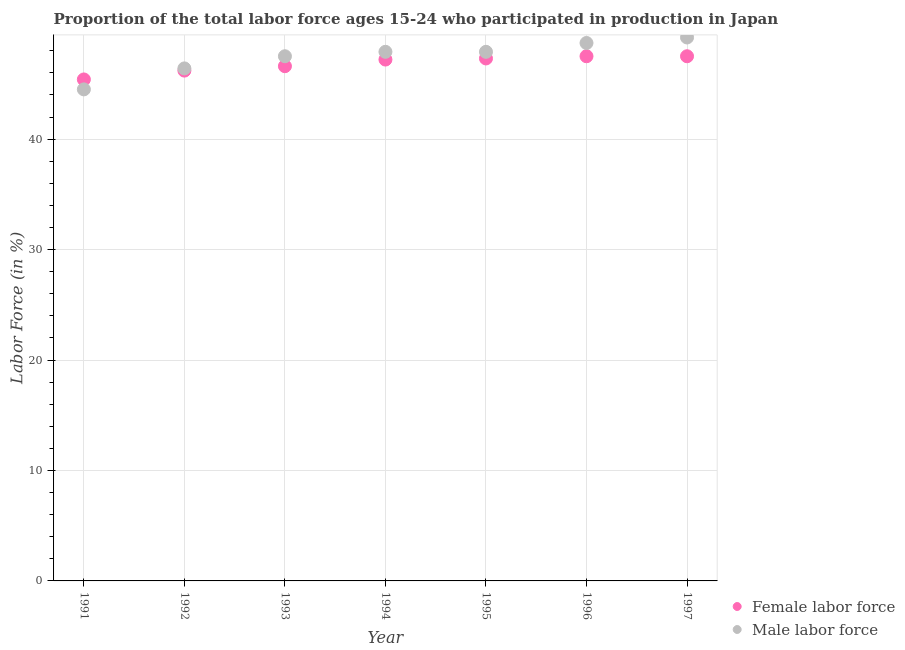What is the percentage of female labor force in 1992?
Make the answer very short. 46.2. Across all years, what is the maximum percentage of male labour force?
Offer a very short reply. 49.2. Across all years, what is the minimum percentage of male labour force?
Offer a terse response. 44.5. In which year was the percentage of male labour force maximum?
Provide a succinct answer. 1997. In which year was the percentage of male labour force minimum?
Your answer should be very brief. 1991. What is the total percentage of female labor force in the graph?
Make the answer very short. 327.7. What is the difference between the percentage of male labour force in 1994 and that in 1996?
Ensure brevity in your answer.  -0.8. What is the difference between the percentage of female labor force in 1995 and the percentage of male labour force in 1992?
Offer a very short reply. 0.9. What is the average percentage of female labor force per year?
Give a very brief answer. 46.81. In the year 1991, what is the difference between the percentage of female labor force and percentage of male labour force?
Offer a terse response. 0.9. What is the ratio of the percentage of male labour force in 1991 to that in 1997?
Offer a terse response. 0.9. Is the percentage of female labor force in 1994 less than that in 1997?
Ensure brevity in your answer.  Yes. Is the difference between the percentage of female labor force in 1995 and 1996 greater than the difference between the percentage of male labour force in 1995 and 1996?
Provide a succinct answer. Yes. What is the difference between the highest and the lowest percentage of female labor force?
Your answer should be compact. 2.1. In how many years, is the percentage of male labour force greater than the average percentage of male labour force taken over all years?
Give a very brief answer. 5. Does the percentage of female labor force monotonically increase over the years?
Offer a very short reply. No. How many dotlines are there?
Offer a very short reply. 2. Does the graph contain any zero values?
Give a very brief answer. No. Does the graph contain grids?
Make the answer very short. Yes. Where does the legend appear in the graph?
Ensure brevity in your answer.  Bottom right. How many legend labels are there?
Offer a terse response. 2. How are the legend labels stacked?
Offer a terse response. Vertical. What is the title of the graph?
Offer a terse response. Proportion of the total labor force ages 15-24 who participated in production in Japan. What is the label or title of the X-axis?
Provide a succinct answer. Year. What is the Labor Force (in %) in Female labor force in 1991?
Ensure brevity in your answer.  45.4. What is the Labor Force (in %) of Male labor force in 1991?
Provide a succinct answer. 44.5. What is the Labor Force (in %) of Female labor force in 1992?
Give a very brief answer. 46.2. What is the Labor Force (in %) of Male labor force in 1992?
Your response must be concise. 46.4. What is the Labor Force (in %) in Female labor force in 1993?
Keep it short and to the point. 46.6. What is the Labor Force (in %) of Male labor force in 1993?
Offer a very short reply. 47.5. What is the Labor Force (in %) in Female labor force in 1994?
Keep it short and to the point. 47.2. What is the Labor Force (in %) in Male labor force in 1994?
Ensure brevity in your answer.  47.9. What is the Labor Force (in %) in Female labor force in 1995?
Offer a very short reply. 47.3. What is the Labor Force (in %) of Male labor force in 1995?
Your answer should be very brief. 47.9. What is the Labor Force (in %) in Female labor force in 1996?
Ensure brevity in your answer.  47.5. What is the Labor Force (in %) of Male labor force in 1996?
Keep it short and to the point. 48.7. What is the Labor Force (in %) of Female labor force in 1997?
Offer a terse response. 47.5. What is the Labor Force (in %) of Male labor force in 1997?
Provide a short and direct response. 49.2. Across all years, what is the maximum Labor Force (in %) of Female labor force?
Keep it short and to the point. 47.5. Across all years, what is the maximum Labor Force (in %) of Male labor force?
Make the answer very short. 49.2. Across all years, what is the minimum Labor Force (in %) of Female labor force?
Provide a short and direct response. 45.4. Across all years, what is the minimum Labor Force (in %) of Male labor force?
Your answer should be compact. 44.5. What is the total Labor Force (in %) in Female labor force in the graph?
Offer a very short reply. 327.7. What is the total Labor Force (in %) in Male labor force in the graph?
Your answer should be very brief. 332.1. What is the difference between the Labor Force (in %) of Female labor force in 1991 and that in 1995?
Ensure brevity in your answer.  -1.9. What is the difference between the Labor Force (in %) of Female labor force in 1992 and that in 1993?
Your answer should be very brief. -0.4. What is the difference between the Labor Force (in %) of Male labor force in 1992 and that in 1993?
Offer a terse response. -1.1. What is the difference between the Labor Force (in %) of Female labor force in 1992 and that in 1994?
Ensure brevity in your answer.  -1. What is the difference between the Labor Force (in %) of Male labor force in 1992 and that in 1994?
Provide a short and direct response. -1.5. What is the difference between the Labor Force (in %) of Female labor force in 1992 and that in 1995?
Ensure brevity in your answer.  -1.1. What is the difference between the Labor Force (in %) of Male labor force in 1992 and that in 1995?
Offer a terse response. -1.5. What is the difference between the Labor Force (in %) of Male labor force in 1992 and that in 1996?
Your answer should be compact. -2.3. What is the difference between the Labor Force (in %) of Female labor force in 1992 and that in 1997?
Ensure brevity in your answer.  -1.3. What is the difference between the Labor Force (in %) in Male labor force in 1992 and that in 1997?
Offer a terse response. -2.8. What is the difference between the Labor Force (in %) of Female labor force in 1993 and that in 1994?
Keep it short and to the point. -0.6. What is the difference between the Labor Force (in %) in Male labor force in 1993 and that in 1994?
Provide a short and direct response. -0.4. What is the difference between the Labor Force (in %) in Male labor force in 1993 and that in 1995?
Give a very brief answer. -0.4. What is the difference between the Labor Force (in %) in Female labor force in 1993 and that in 1997?
Your answer should be very brief. -0.9. What is the difference between the Labor Force (in %) in Male labor force in 1993 and that in 1997?
Your answer should be compact. -1.7. What is the difference between the Labor Force (in %) of Male labor force in 1994 and that in 1995?
Ensure brevity in your answer.  0. What is the difference between the Labor Force (in %) of Female labor force in 1994 and that in 1996?
Offer a very short reply. -0.3. What is the difference between the Labor Force (in %) of Male labor force in 1994 and that in 1996?
Ensure brevity in your answer.  -0.8. What is the difference between the Labor Force (in %) in Female labor force in 1995 and that in 1996?
Your response must be concise. -0.2. What is the difference between the Labor Force (in %) in Male labor force in 1995 and that in 1996?
Offer a terse response. -0.8. What is the difference between the Labor Force (in %) of Female labor force in 1995 and that in 1997?
Keep it short and to the point. -0.2. What is the difference between the Labor Force (in %) of Male labor force in 1995 and that in 1997?
Provide a short and direct response. -1.3. What is the difference between the Labor Force (in %) in Male labor force in 1996 and that in 1997?
Ensure brevity in your answer.  -0.5. What is the difference between the Labor Force (in %) in Female labor force in 1991 and the Labor Force (in %) in Male labor force in 1992?
Make the answer very short. -1. What is the difference between the Labor Force (in %) of Female labor force in 1991 and the Labor Force (in %) of Male labor force in 1995?
Give a very brief answer. -2.5. What is the difference between the Labor Force (in %) in Female labor force in 1991 and the Labor Force (in %) in Male labor force in 1997?
Keep it short and to the point. -3.8. What is the difference between the Labor Force (in %) in Female labor force in 1992 and the Labor Force (in %) in Male labor force in 1993?
Keep it short and to the point. -1.3. What is the difference between the Labor Force (in %) in Female labor force in 1992 and the Labor Force (in %) in Male labor force in 1997?
Offer a very short reply. -3. What is the difference between the Labor Force (in %) in Female labor force in 1993 and the Labor Force (in %) in Male labor force in 1994?
Your response must be concise. -1.3. What is the difference between the Labor Force (in %) of Female labor force in 1995 and the Labor Force (in %) of Male labor force in 1996?
Offer a terse response. -1.4. What is the difference between the Labor Force (in %) of Female labor force in 1995 and the Labor Force (in %) of Male labor force in 1997?
Your answer should be very brief. -1.9. What is the average Labor Force (in %) of Female labor force per year?
Your answer should be compact. 46.81. What is the average Labor Force (in %) of Male labor force per year?
Offer a very short reply. 47.44. In the year 1991, what is the difference between the Labor Force (in %) in Female labor force and Labor Force (in %) in Male labor force?
Ensure brevity in your answer.  0.9. In the year 1993, what is the difference between the Labor Force (in %) of Female labor force and Labor Force (in %) of Male labor force?
Keep it short and to the point. -0.9. In the year 1994, what is the difference between the Labor Force (in %) in Female labor force and Labor Force (in %) in Male labor force?
Your answer should be very brief. -0.7. In the year 1995, what is the difference between the Labor Force (in %) in Female labor force and Labor Force (in %) in Male labor force?
Provide a short and direct response. -0.6. In the year 1996, what is the difference between the Labor Force (in %) of Female labor force and Labor Force (in %) of Male labor force?
Offer a terse response. -1.2. What is the ratio of the Labor Force (in %) in Female labor force in 1991 to that in 1992?
Ensure brevity in your answer.  0.98. What is the ratio of the Labor Force (in %) of Male labor force in 1991 to that in 1992?
Your answer should be compact. 0.96. What is the ratio of the Labor Force (in %) of Female labor force in 1991 to that in 1993?
Ensure brevity in your answer.  0.97. What is the ratio of the Labor Force (in %) of Male labor force in 1991 to that in 1993?
Ensure brevity in your answer.  0.94. What is the ratio of the Labor Force (in %) in Female labor force in 1991 to that in 1994?
Give a very brief answer. 0.96. What is the ratio of the Labor Force (in %) of Male labor force in 1991 to that in 1994?
Your answer should be compact. 0.93. What is the ratio of the Labor Force (in %) in Female labor force in 1991 to that in 1995?
Ensure brevity in your answer.  0.96. What is the ratio of the Labor Force (in %) of Male labor force in 1991 to that in 1995?
Your answer should be compact. 0.93. What is the ratio of the Labor Force (in %) in Female labor force in 1991 to that in 1996?
Your answer should be very brief. 0.96. What is the ratio of the Labor Force (in %) of Male labor force in 1991 to that in 1996?
Your answer should be compact. 0.91. What is the ratio of the Labor Force (in %) in Female labor force in 1991 to that in 1997?
Your response must be concise. 0.96. What is the ratio of the Labor Force (in %) in Male labor force in 1991 to that in 1997?
Your answer should be very brief. 0.9. What is the ratio of the Labor Force (in %) of Male labor force in 1992 to that in 1993?
Your answer should be very brief. 0.98. What is the ratio of the Labor Force (in %) of Female labor force in 1992 to that in 1994?
Offer a terse response. 0.98. What is the ratio of the Labor Force (in %) of Male labor force in 1992 to that in 1994?
Keep it short and to the point. 0.97. What is the ratio of the Labor Force (in %) in Female labor force in 1992 to that in 1995?
Your response must be concise. 0.98. What is the ratio of the Labor Force (in %) of Male labor force in 1992 to that in 1995?
Make the answer very short. 0.97. What is the ratio of the Labor Force (in %) of Female labor force in 1992 to that in 1996?
Provide a short and direct response. 0.97. What is the ratio of the Labor Force (in %) in Male labor force in 1992 to that in 1996?
Your response must be concise. 0.95. What is the ratio of the Labor Force (in %) of Female labor force in 1992 to that in 1997?
Make the answer very short. 0.97. What is the ratio of the Labor Force (in %) in Male labor force in 1992 to that in 1997?
Offer a terse response. 0.94. What is the ratio of the Labor Force (in %) of Female labor force in 1993 to that in 1994?
Offer a terse response. 0.99. What is the ratio of the Labor Force (in %) of Male labor force in 1993 to that in 1994?
Offer a terse response. 0.99. What is the ratio of the Labor Force (in %) in Female labor force in 1993 to that in 1995?
Your response must be concise. 0.99. What is the ratio of the Labor Force (in %) of Female labor force in 1993 to that in 1996?
Offer a very short reply. 0.98. What is the ratio of the Labor Force (in %) of Male labor force in 1993 to that in 1996?
Keep it short and to the point. 0.98. What is the ratio of the Labor Force (in %) in Female labor force in 1993 to that in 1997?
Give a very brief answer. 0.98. What is the ratio of the Labor Force (in %) of Male labor force in 1993 to that in 1997?
Make the answer very short. 0.97. What is the ratio of the Labor Force (in %) of Female labor force in 1994 to that in 1995?
Offer a very short reply. 1. What is the ratio of the Labor Force (in %) of Male labor force in 1994 to that in 1996?
Offer a very short reply. 0.98. What is the ratio of the Labor Force (in %) in Male labor force in 1994 to that in 1997?
Give a very brief answer. 0.97. What is the ratio of the Labor Force (in %) in Female labor force in 1995 to that in 1996?
Give a very brief answer. 1. What is the ratio of the Labor Force (in %) in Male labor force in 1995 to that in 1996?
Your response must be concise. 0.98. What is the ratio of the Labor Force (in %) in Male labor force in 1995 to that in 1997?
Your answer should be very brief. 0.97. What is the ratio of the Labor Force (in %) in Male labor force in 1996 to that in 1997?
Give a very brief answer. 0.99. What is the difference between the highest and the second highest Labor Force (in %) of Male labor force?
Your answer should be compact. 0.5. What is the difference between the highest and the lowest Labor Force (in %) in Female labor force?
Your response must be concise. 2.1. What is the difference between the highest and the lowest Labor Force (in %) in Male labor force?
Provide a succinct answer. 4.7. 